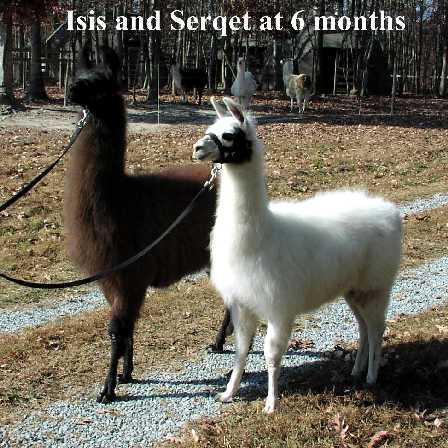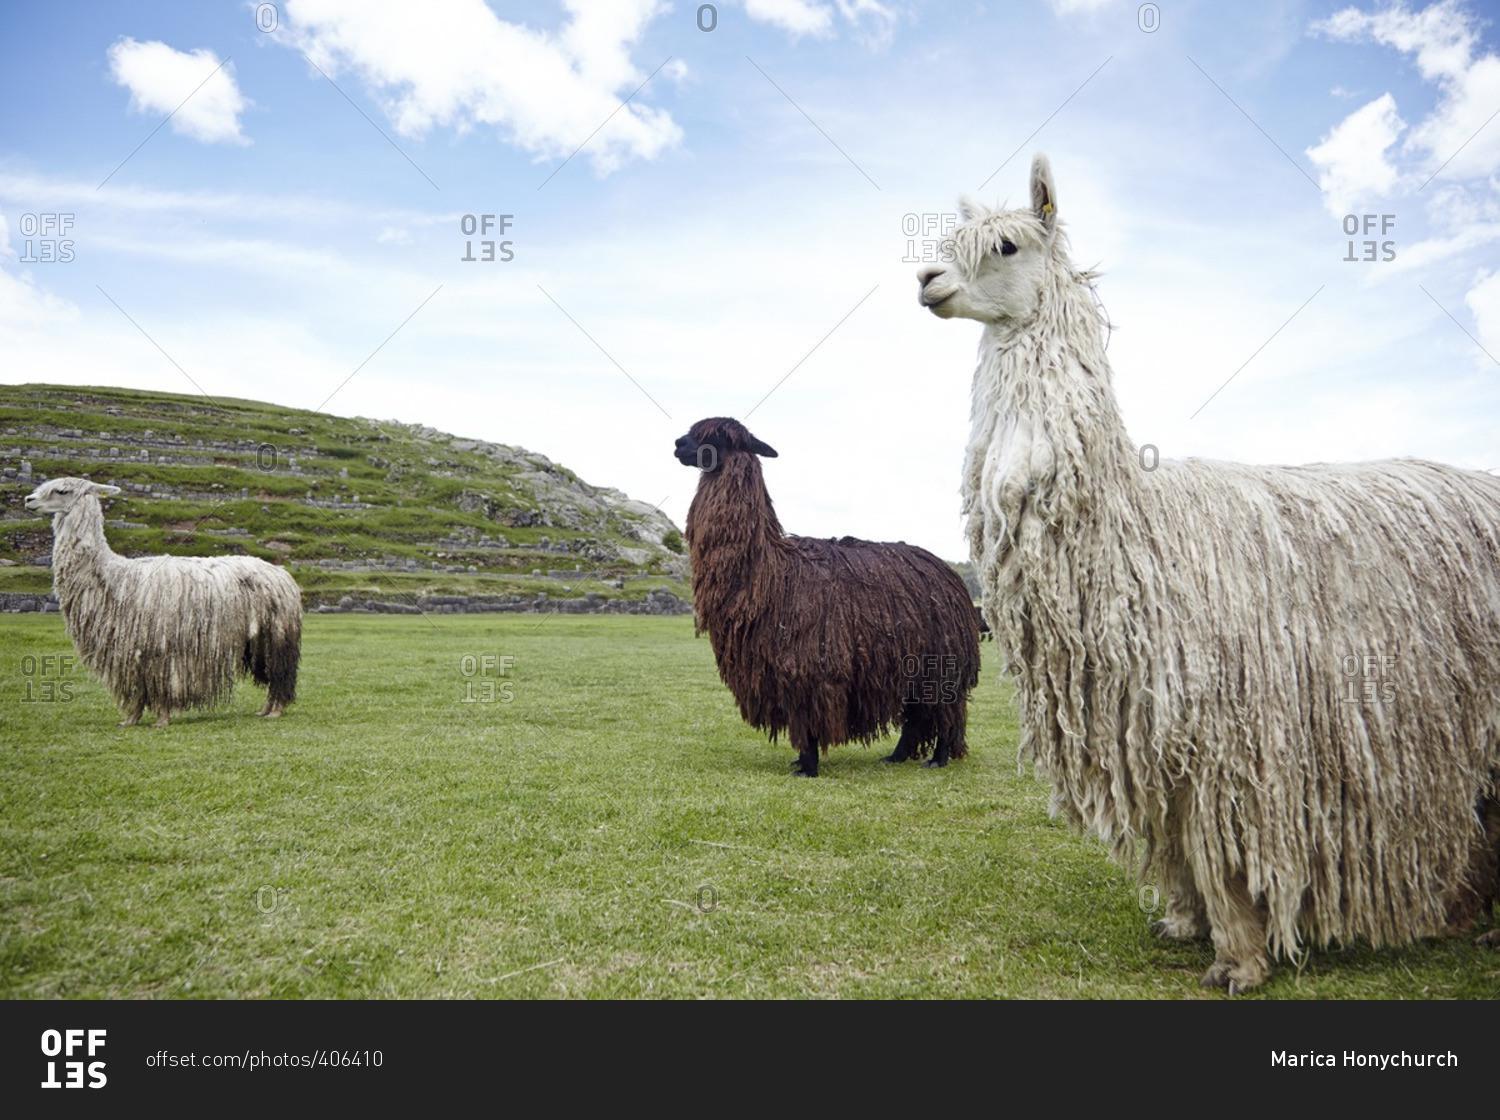The first image is the image on the left, the second image is the image on the right. For the images shown, is this caption "One image shows three forward-facing llamas with non-shaggy faces, and the other image contains three llamas with shaggy wool." true? Answer yes or no. No. The first image is the image on the left, the second image is the image on the right. Given the left and right images, does the statement "The left and right image contains the same number of Llamas." hold true? Answer yes or no. No. 